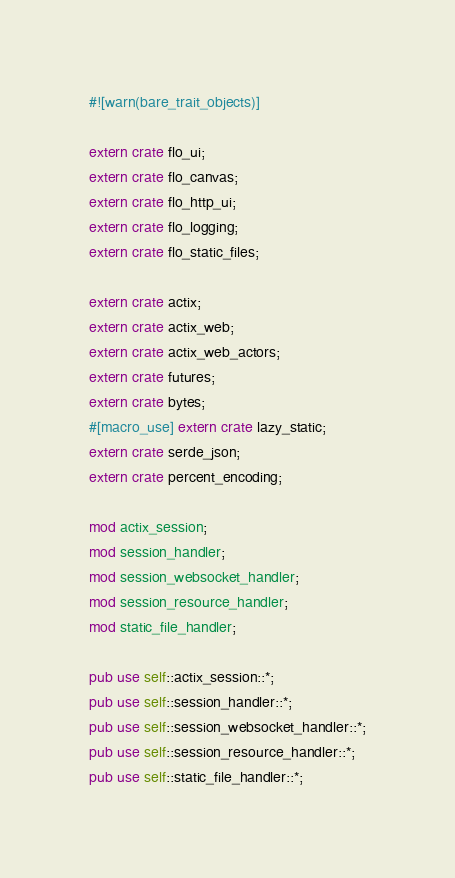Convert code to text. <code><loc_0><loc_0><loc_500><loc_500><_Rust_>#![warn(bare_trait_objects)]

extern crate flo_ui;
extern crate flo_canvas;
extern crate flo_http_ui;
extern crate flo_logging;
extern crate flo_static_files;

extern crate actix;
extern crate actix_web;
extern crate actix_web_actors;
extern crate futures;
extern crate bytes;
#[macro_use] extern crate lazy_static;
extern crate serde_json;
extern crate percent_encoding;

mod actix_session;
mod session_handler;
mod session_websocket_handler;
mod session_resource_handler;
mod static_file_handler;

pub use self::actix_session::*;
pub use self::session_handler::*;
pub use self::session_websocket_handler::*;
pub use self::session_resource_handler::*;
pub use self::static_file_handler::*;
</code> 